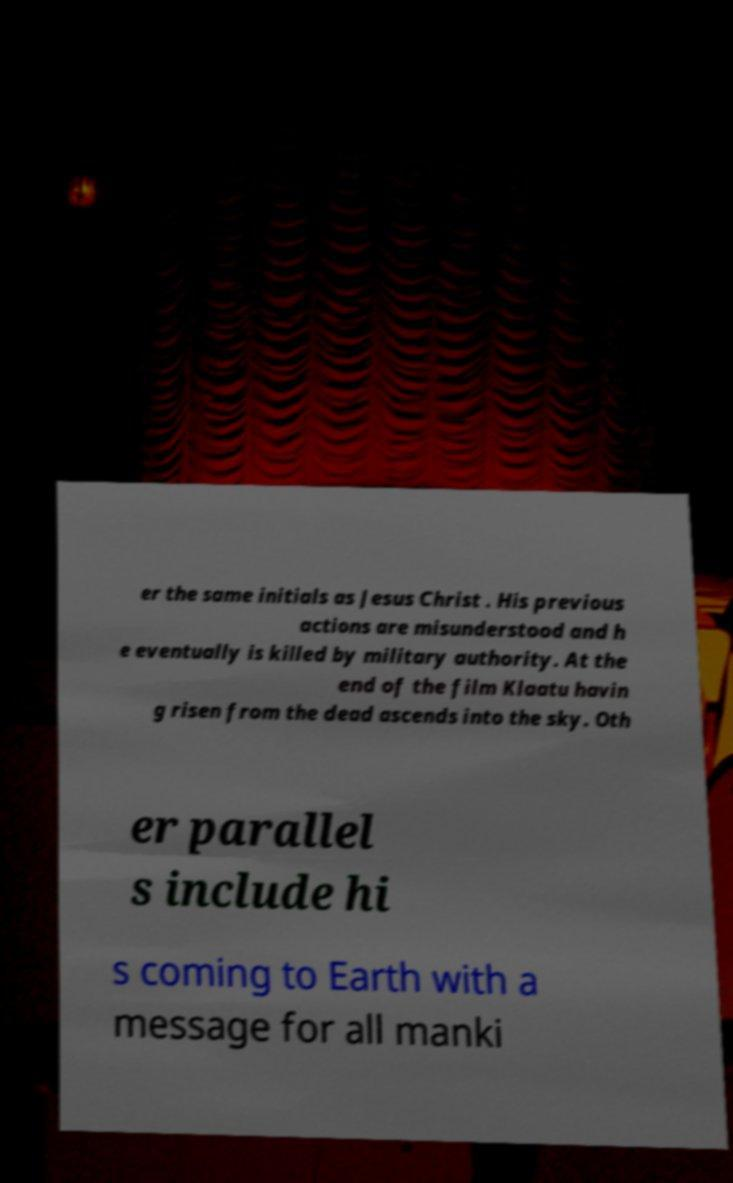Could you extract and type out the text from this image? er the same initials as Jesus Christ . His previous actions are misunderstood and h e eventually is killed by military authority. At the end of the film Klaatu havin g risen from the dead ascends into the sky. Oth er parallel s include hi s coming to Earth with a message for all manki 